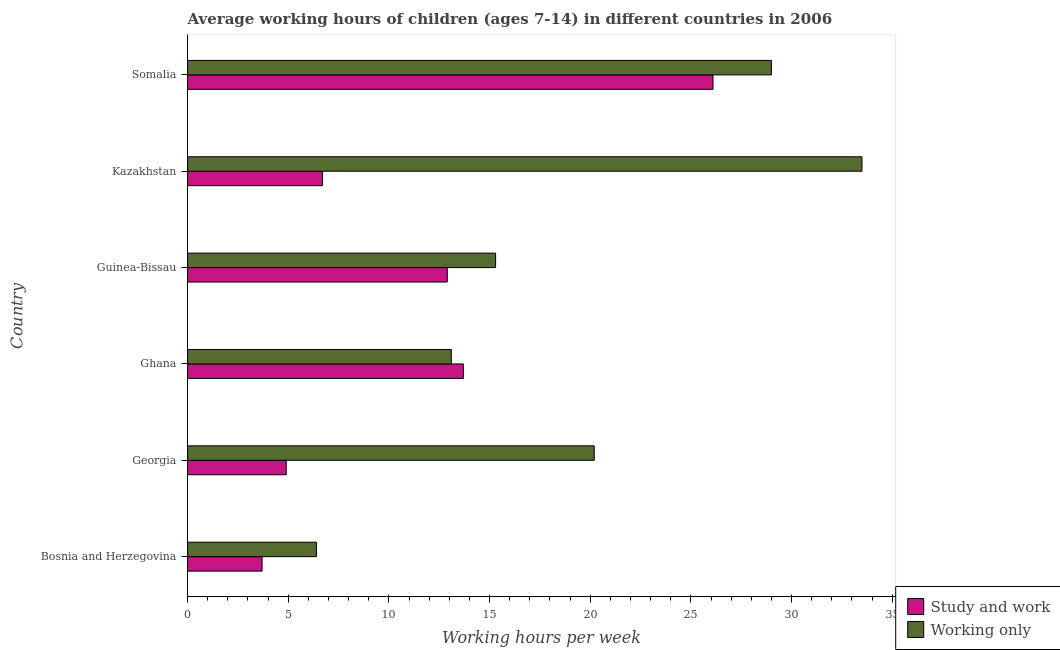Are the number of bars on each tick of the Y-axis equal?
Provide a succinct answer. Yes. How many bars are there on the 6th tick from the bottom?
Give a very brief answer. 2. What is the label of the 5th group of bars from the top?
Keep it short and to the point. Georgia. What is the average working hour of children involved in study and work in Bosnia and Herzegovina?
Keep it short and to the point. 3.7. Across all countries, what is the maximum average working hour of children involved in only work?
Provide a succinct answer. 33.5. Across all countries, what is the minimum average working hour of children involved in only work?
Give a very brief answer. 6.4. In which country was the average working hour of children involved in study and work maximum?
Provide a succinct answer. Somalia. In which country was the average working hour of children involved in only work minimum?
Your answer should be very brief. Bosnia and Herzegovina. What is the total average working hour of children involved in only work in the graph?
Your response must be concise. 117.5. What is the difference between the average working hour of children involved in only work in Ghana and that in Kazakhstan?
Provide a short and direct response. -20.4. What is the difference between the average working hour of children involved in study and work in Bosnia and Herzegovina and the average working hour of children involved in only work in Kazakhstan?
Your response must be concise. -29.8. What is the average average working hour of children involved in only work per country?
Your answer should be very brief. 19.58. What is the difference between the average working hour of children involved in only work and average working hour of children involved in study and work in Kazakhstan?
Make the answer very short. 26.8. What is the ratio of the average working hour of children involved in only work in Bosnia and Herzegovina to that in Georgia?
Keep it short and to the point. 0.32. Is the average working hour of children involved in study and work in Bosnia and Herzegovina less than that in Kazakhstan?
Offer a very short reply. Yes. Is the difference between the average working hour of children involved in only work in Ghana and Somalia greater than the difference between the average working hour of children involved in study and work in Ghana and Somalia?
Provide a succinct answer. No. What is the difference between the highest and the lowest average working hour of children involved in only work?
Make the answer very short. 27.1. Is the sum of the average working hour of children involved in only work in Bosnia and Herzegovina and Kazakhstan greater than the maximum average working hour of children involved in study and work across all countries?
Offer a terse response. Yes. What does the 2nd bar from the top in Guinea-Bissau represents?
Keep it short and to the point. Study and work. What does the 2nd bar from the bottom in Georgia represents?
Keep it short and to the point. Working only. How many bars are there?
Keep it short and to the point. 12. Are all the bars in the graph horizontal?
Provide a succinct answer. Yes. How many countries are there in the graph?
Your answer should be very brief. 6. What is the difference between two consecutive major ticks on the X-axis?
Keep it short and to the point. 5. Are the values on the major ticks of X-axis written in scientific E-notation?
Offer a terse response. No. Does the graph contain any zero values?
Offer a very short reply. No. Where does the legend appear in the graph?
Your answer should be very brief. Bottom right. How many legend labels are there?
Your response must be concise. 2. How are the legend labels stacked?
Give a very brief answer. Vertical. What is the title of the graph?
Give a very brief answer. Average working hours of children (ages 7-14) in different countries in 2006. What is the label or title of the X-axis?
Your answer should be very brief. Working hours per week. What is the Working hours per week in Study and work in Bosnia and Herzegovina?
Your answer should be very brief. 3.7. What is the Working hours per week in Working only in Bosnia and Herzegovina?
Provide a short and direct response. 6.4. What is the Working hours per week of Study and work in Georgia?
Make the answer very short. 4.9. What is the Working hours per week of Working only in Georgia?
Your answer should be compact. 20.2. What is the Working hours per week of Study and work in Guinea-Bissau?
Your answer should be very brief. 12.9. What is the Working hours per week in Working only in Kazakhstan?
Your answer should be very brief. 33.5. What is the Working hours per week of Study and work in Somalia?
Provide a short and direct response. 26.1. What is the Working hours per week in Working only in Somalia?
Keep it short and to the point. 29. Across all countries, what is the maximum Working hours per week in Study and work?
Ensure brevity in your answer.  26.1. Across all countries, what is the maximum Working hours per week in Working only?
Keep it short and to the point. 33.5. Across all countries, what is the minimum Working hours per week in Study and work?
Offer a very short reply. 3.7. What is the total Working hours per week of Working only in the graph?
Your answer should be compact. 117.5. What is the difference between the Working hours per week in Working only in Bosnia and Herzegovina and that in Georgia?
Ensure brevity in your answer.  -13.8. What is the difference between the Working hours per week of Working only in Bosnia and Herzegovina and that in Kazakhstan?
Provide a succinct answer. -27.1. What is the difference between the Working hours per week in Study and work in Bosnia and Herzegovina and that in Somalia?
Keep it short and to the point. -22.4. What is the difference between the Working hours per week of Working only in Bosnia and Herzegovina and that in Somalia?
Your response must be concise. -22.6. What is the difference between the Working hours per week in Study and work in Georgia and that in Ghana?
Your answer should be compact. -8.8. What is the difference between the Working hours per week of Study and work in Georgia and that in Guinea-Bissau?
Keep it short and to the point. -8. What is the difference between the Working hours per week in Study and work in Georgia and that in Kazakhstan?
Make the answer very short. -1.8. What is the difference between the Working hours per week of Study and work in Georgia and that in Somalia?
Your answer should be compact. -21.2. What is the difference between the Working hours per week of Working only in Ghana and that in Guinea-Bissau?
Your answer should be compact. -2.2. What is the difference between the Working hours per week in Working only in Ghana and that in Kazakhstan?
Ensure brevity in your answer.  -20.4. What is the difference between the Working hours per week in Study and work in Ghana and that in Somalia?
Give a very brief answer. -12.4. What is the difference between the Working hours per week in Working only in Ghana and that in Somalia?
Your response must be concise. -15.9. What is the difference between the Working hours per week in Working only in Guinea-Bissau and that in Kazakhstan?
Your answer should be compact. -18.2. What is the difference between the Working hours per week of Study and work in Guinea-Bissau and that in Somalia?
Make the answer very short. -13.2. What is the difference between the Working hours per week in Working only in Guinea-Bissau and that in Somalia?
Keep it short and to the point. -13.7. What is the difference between the Working hours per week of Study and work in Kazakhstan and that in Somalia?
Make the answer very short. -19.4. What is the difference between the Working hours per week of Study and work in Bosnia and Herzegovina and the Working hours per week of Working only in Georgia?
Your response must be concise. -16.5. What is the difference between the Working hours per week of Study and work in Bosnia and Herzegovina and the Working hours per week of Working only in Guinea-Bissau?
Provide a short and direct response. -11.6. What is the difference between the Working hours per week of Study and work in Bosnia and Herzegovina and the Working hours per week of Working only in Kazakhstan?
Give a very brief answer. -29.8. What is the difference between the Working hours per week of Study and work in Bosnia and Herzegovina and the Working hours per week of Working only in Somalia?
Your response must be concise. -25.3. What is the difference between the Working hours per week of Study and work in Georgia and the Working hours per week of Working only in Ghana?
Provide a succinct answer. -8.2. What is the difference between the Working hours per week in Study and work in Georgia and the Working hours per week in Working only in Kazakhstan?
Ensure brevity in your answer.  -28.6. What is the difference between the Working hours per week in Study and work in Georgia and the Working hours per week in Working only in Somalia?
Offer a terse response. -24.1. What is the difference between the Working hours per week of Study and work in Ghana and the Working hours per week of Working only in Guinea-Bissau?
Offer a very short reply. -1.6. What is the difference between the Working hours per week in Study and work in Ghana and the Working hours per week in Working only in Kazakhstan?
Keep it short and to the point. -19.8. What is the difference between the Working hours per week in Study and work in Ghana and the Working hours per week in Working only in Somalia?
Keep it short and to the point. -15.3. What is the difference between the Working hours per week in Study and work in Guinea-Bissau and the Working hours per week in Working only in Kazakhstan?
Give a very brief answer. -20.6. What is the difference between the Working hours per week in Study and work in Guinea-Bissau and the Working hours per week in Working only in Somalia?
Make the answer very short. -16.1. What is the difference between the Working hours per week in Study and work in Kazakhstan and the Working hours per week in Working only in Somalia?
Give a very brief answer. -22.3. What is the average Working hours per week in Study and work per country?
Make the answer very short. 11.33. What is the average Working hours per week of Working only per country?
Offer a very short reply. 19.58. What is the difference between the Working hours per week of Study and work and Working hours per week of Working only in Georgia?
Keep it short and to the point. -15.3. What is the difference between the Working hours per week of Study and work and Working hours per week of Working only in Ghana?
Your answer should be very brief. 0.6. What is the difference between the Working hours per week in Study and work and Working hours per week in Working only in Guinea-Bissau?
Your answer should be very brief. -2.4. What is the difference between the Working hours per week in Study and work and Working hours per week in Working only in Kazakhstan?
Your answer should be very brief. -26.8. What is the ratio of the Working hours per week of Study and work in Bosnia and Herzegovina to that in Georgia?
Your response must be concise. 0.76. What is the ratio of the Working hours per week in Working only in Bosnia and Herzegovina to that in Georgia?
Offer a very short reply. 0.32. What is the ratio of the Working hours per week in Study and work in Bosnia and Herzegovina to that in Ghana?
Ensure brevity in your answer.  0.27. What is the ratio of the Working hours per week of Working only in Bosnia and Herzegovina to that in Ghana?
Your answer should be very brief. 0.49. What is the ratio of the Working hours per week of Study and work in Bosnia and Herzegovina to that in Guinea-Bissau?
Provide a short and direct response. 0.29. What is the ratio of the Working hours per week in Working only in Bosnia and Herzegovina to that in Guinea-Bissau?
Give a very brief answer. 0.42. What is the ratio of the Working hours per week of Study and work in Bosnia and Herzegovina to that in Kazakhstan?
Keep it short and to the point. 0.55. What is the ratio of the Working hours per week in Working only in Bosnia and Herzegovina to that in Kazakhstan?
Your answer should be very brief. 0.19. What is the ratio of the Working hours per week in Study and work in Bosnia and Herzegovina to that in Somalia?
Keep it short and to the point. 0.14. What is the ratio of the Working hours per week in Working only in Bosnia and Herzegovina to that in Somalia?
Keep it short and to the point. 0.22. What is the ratio of the Working hours per week of Study and work in Georgia to that in Ghana?
Ensure brevity in your answer.  0.36. What is the ratio of the Working hours per week in Working only in Georgia to that in Ghana?
Make the answer very short. 1.54. What is the ratio of the Working hours per week of Study and work in Georgia to that in Guinea-Bissau?
Your answer should be compact. 0.38. What is the ratio of the Working hours per week of Working only in Georgia to that in Guinea-Bissau?
Offer a very short reply. 1.32. What is the ratio of the Working hours per week of Study and work in Georgia to that in Kazakhstan?
Offer a very short reply. 0.73. What is the ratio of the Working hours per week in Working only in Georgia to that in Kazakhstan?
Your answer should be compact. 0.6. What is the ratio of the Working hours per week in Study and work in Georgia to that in Somalia?
Your answer should be compact. 0.19. What is the ratio of the Working hours per week in Working only in Georgia to that in Somalia?
Provide a short and direct response. 0.7. What is the ratio of the Working hours per week in Study and work in Ghana to that in Guinea-Bissau?
Keep it short and to the point. 1.06. What is the ratio of the Working hours per week in Working only in Ghana to that in Guinea-Bissau?
Your answer should be compact. 0.86. What is the ratio of the Working hours per week in Study and work in Ghana to that in Kazakhstan?
Keep it short and to the point. 2.04. What is the ratio of the Working hours per week in Working only in Ghana to that in Kazakhstan?
Give a very brief answer. 0.39. What is the ratio of the Working hours per week of Study and work in Ghana to that in Somalia?
Your answer should be very brief. 0.52. What is the ratio of the Working hours per week in Working only in Ghana to that in Somalia?
Keep it short and to the point. 0.45. What is the ratio of the Working hours per week of Study and work in Guinea-Bissau to that in Kazakhstan?
Your response must be concise. 1.93. What is the ratio of the Working hours per week in Working only in Guinea-Bissau to that in Kazakhstan?
Offer a very short reply. 0.46. What is the ratio of the Working hours per week of Study and work in Guinea-Bissau to that in Somalia?
Provide a short and direct response. 0.49. What is the ratio of the Working hours per week in Working only in Guinea-Bissau to that in Somalia?
Your answer should be very brief. 0.53. What is the ratio of the Working hours per week of Study and work in Kazakhstan to that in Somalia?
Offer a terse response. 0.26. What is the ratio of the Working hours per week of Working only in Kazakhstan to that in Somalia?
Offer a terse response. 1.16. What is the difference between the highest and the lowest Working hours per week in Study and work?
Keep it short and to the point. 22.4. What is the difference between the highest and the lowest Working hours per week in Working only?
Your response must be concise. 27.1. 